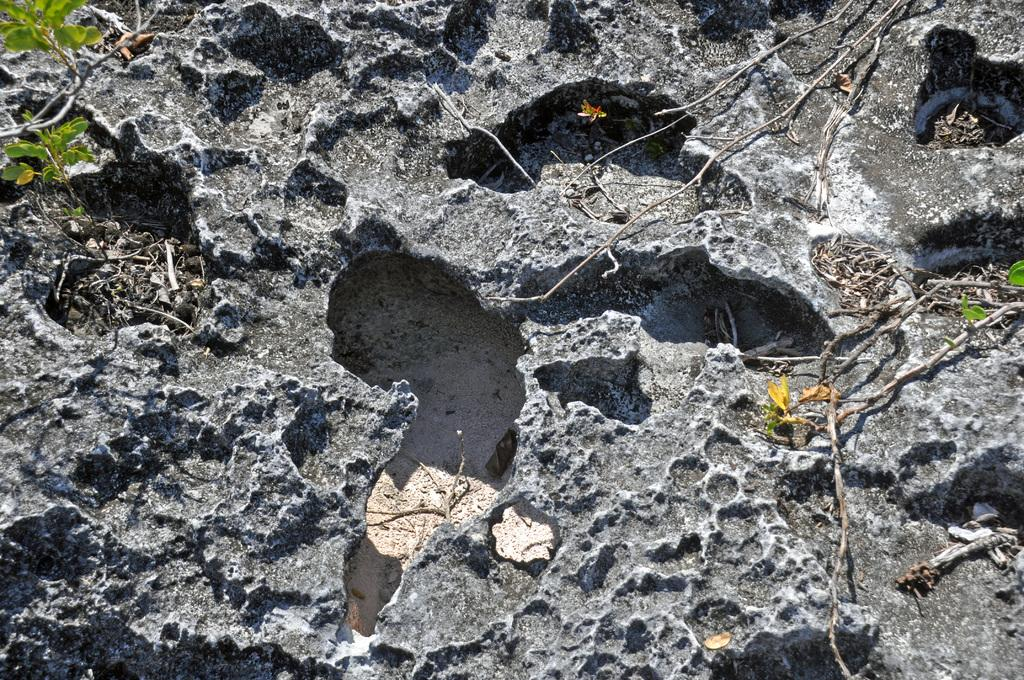What is the main subject of the image? The main subject of the image is a surface of a rock. Where is the rock located in the image? The rock is in the middle of the image. What type of board is visible in the image? There is no board present in the image; it only features a surface of a rock. What year is depicted in the image? The image does not depict any specific year or time period; it only shows a rock surface. 